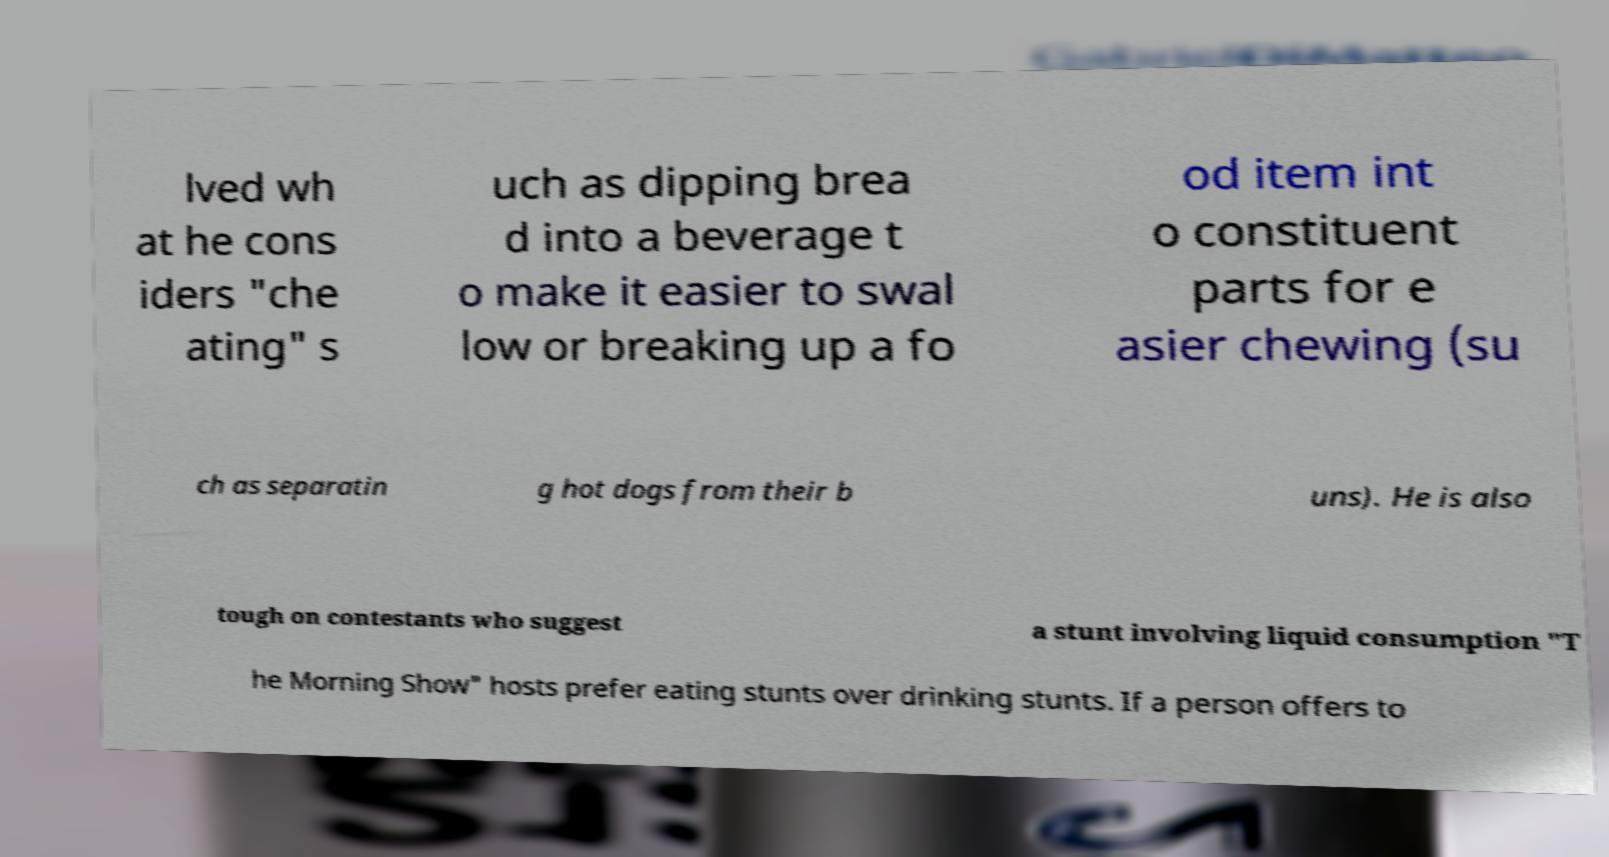Can you read and provide the text displayed in the image?This photo seems to have some interesting text. Can you extract and type it out for me? lved wh at he cons iders "che ating" s uch as dipping brea d into a beverage t o make it easier to swal low or breaking up a fo od item int o constituent parts for e asier chewing (su ch as separatin g hot dogs from their b uns). He is also tough on contestants who suggest a stunt involving liquid consumption "T he Morning Show" hosts prefer eating stunts over drinking stunts. If a person offers to 